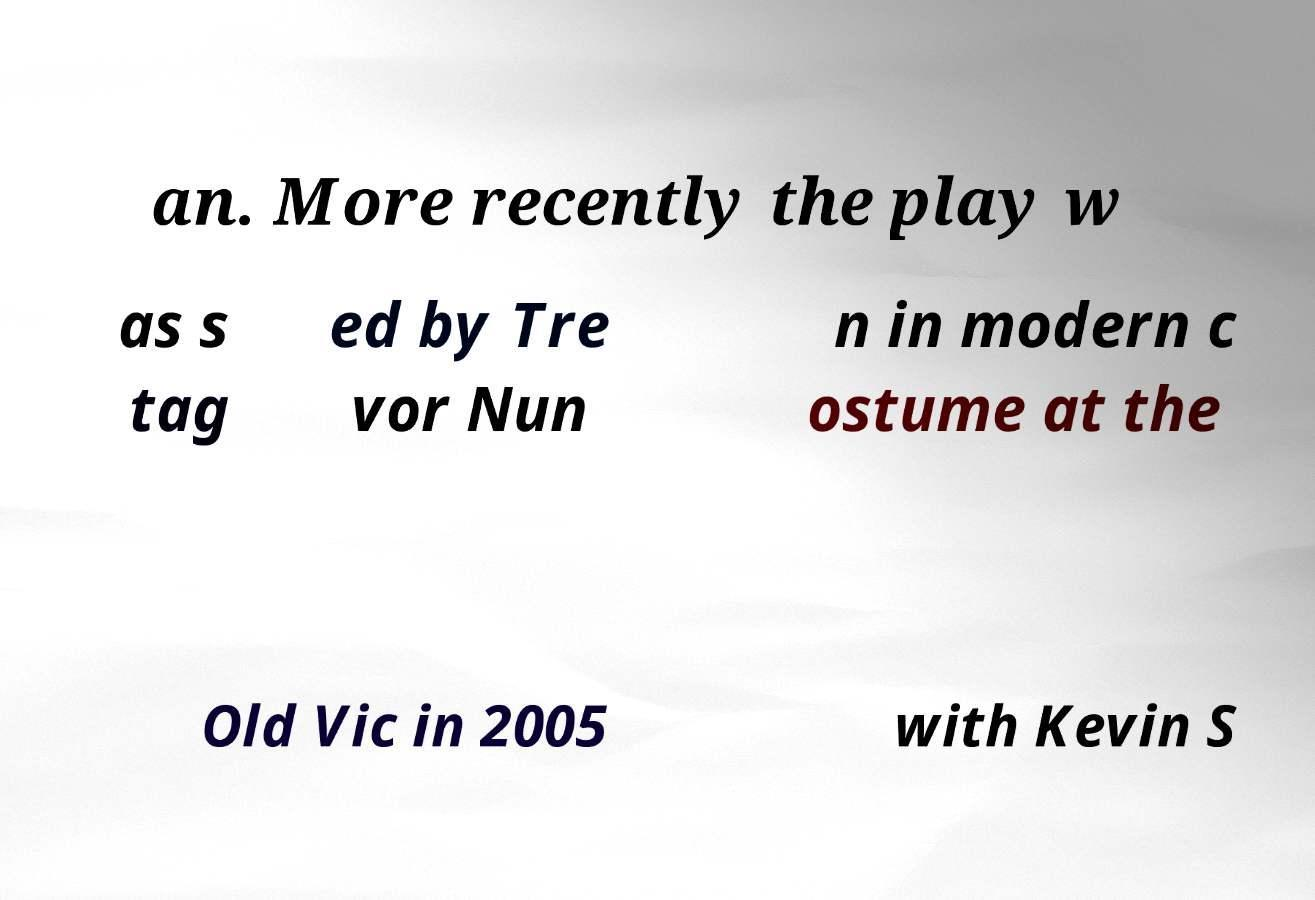Can you read and provide the text displayed in the image?This photo seems to have some interesting text. Can you extract and type it out for me? an. More recently the play w as s tag ed by Tre vor Nun n in modern c ostume at the Old Vic in 2005 with Kevin S 